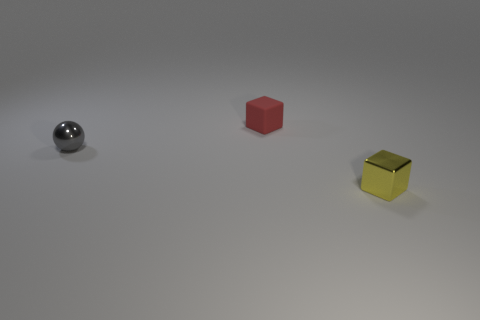There is a red rubber object that is left of the yellow block; is it the same size as the small yellow metal thing?
Offer a very short reply. Yes. How many objects are things that are behind the yellow object or blocks in front of the small gray shiny thing?
Give a very brief answer. 3. Is the metallic cube the same color as the small metallic sphere?
Offer a very short reply. No. Are there fewer tiny red blocks to the right of the red thing than metallic blocks that are behind the yellow object?
Offer a very short reply. No. Is the material of the small sphere the same as the tiny red cube?
Make the answer very short. No. There is a thing that is both in front of the red cube and to the right of the gray ball; what size is it?
Offer a very short reply. Small. What is the shape of the other shiny object that is the same size as the gray metallic object?
Keep it short and to the point. Cube. What is the material of the small cube that is left of the block in front of the tiny cube that is behind the gray shiny sphere?
Your answer should be very brief. Rubber. Is the shape of the tiny metallic thing that is in front of the tiny gray metal object the same as the object on the left side of the matte cube?
Provide a succinct answer. No. What number of other objects are there of the same material as the red object?
Your answer should be very brief. 0. 